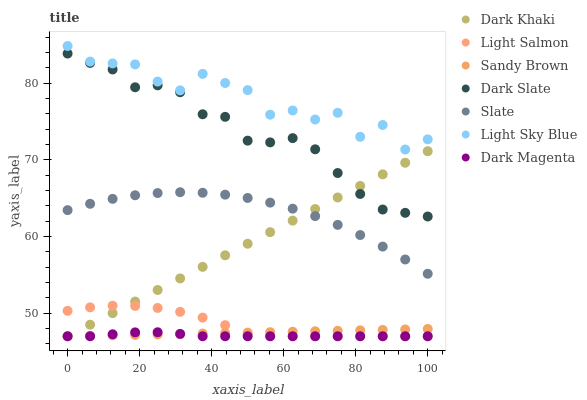Does Dark Magenta have the minimum area under the curve?
Answer yes or no. Yes. Does Light Sky Blue have the maximum area under the curve?
Answer yes or no. Yes. Does Slate have the minimum area under the curve?
Answer yes or no. No. Does Slate have the maximum area under the curve?
Answer yes or no. No. Is Sandy Brown the smoothest?
Answer yes or no. Yes. Is Light Sky Blue the roughest?
Answer yes or no. Yes. Is Dark Magenta the smoothest?
Answer yes or no. No. Is Dark Magenta the roughest?
Answer yes or no. No. Does Light Salmon have the lowest value?
Answer yes or no. Yes. Does Slate have the lowest value?
Answer yes or no. No. Does Light Sky Blue have the highest value?
Answer yes or no. Yes. Does Slate have the highest value?
Answer yes or no. No. Is Light Salmon less than Slate?
Answer yes or no. Yes. Is Light Sky Blue greater than Slate?
Answer yes or no. Yes. Does Dark Magenta intersect Dark Khaki?
Answer yes or no. Yes. Is Dark Magenta less than Dark Khaki?
Answer yes or no. No. Is Dark Magenta greater than Dark Khaki?
Answer yes or no. No. Does Light Salmon intersect Slate?
Answer yes or no. No. 